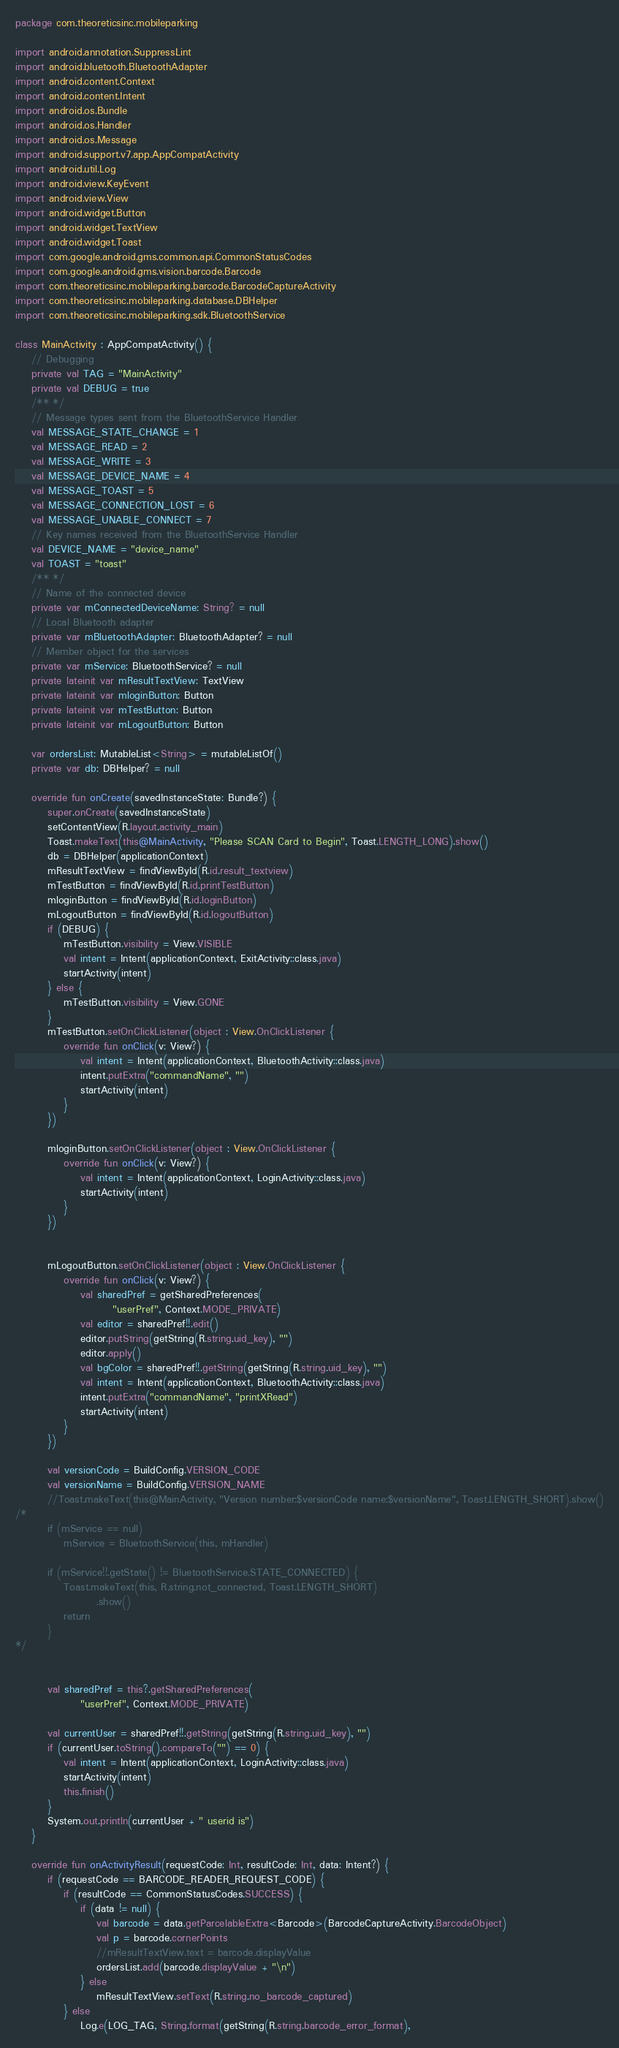<code> <loc_0><loc_0><loc_500><loc_500><_Kotlin_>package com.theoreticsinc.mobileparking

import android.annotation.SuppressLint
import android.bluetooth.BluetoothAdapter
import android.content.Context
import android.content.Intent
import android.os.Bundle
import android.os.Handler
import android.os.Message
import android.support.v7.app.AppCompatActivity
import android.util.Log
import android.view.KeyEvent
import android.view.View
import android.widget.Button
import android.widget.TextView
import android.widget.Toast
import com.google.android.gms.common.api.CommonStatusCodes
import com.google.android.gms.vision.barcode.Barcode
import com.theoreticsinc.mobileparking.barcode.BarcodeCaptureActivity
import com.theoreticsinc.mobileparking.database.DBHelper
import com.theoreticsinc.mobileparking.sdk.BluetoothService

class MainActivity : AppCompatActivity() {
    // Debugging
    private val TAG = "MainActivity"
    private val DEBUG = true
    /** */
    // Message types sent from the BluetoothService Handler
    val MESSAGE_STATE_CHANGE = 1
    val MESSAGE_READ = 2
    val MESSAGE_WRITE = 3
    val MESSAGE_DEVICE_NAME = 4
    val MESSAGE_TOAST = 5
    val MESSAGE_CONNECTION_LOST = 6
    val MESSAGE_UNABLE_CONNECT = 7
    // Key names received from the BluetoothService Handler
    val DEVICE_NAME = "device_name"
    val TOAST = "toast"
    /** */
    // Name of the connected device
    private var mConnectedDeviceName: String? = null
    // Local Bluetooth adapter
    private var mBluetoothAdapter: BluetoothAdapter? = null
    // Member object for the services
    private var mService: BluetoothService? = null
    private lateinit var mResultTextView: TextView
    private lateinit var mloginButton: Button
    private lateinit var mTestButton: Button
    private lateinit var mLogoutButton: Button

    var ordersList: MutableList<String> = mutableListOf()
    private var db: DBHelper? = null

    override fun onCreate(savedInstanceState: Bundle?) {
        super.onCreate(savedInstanceState)
        setContentView(R.layout.activity_main)
        Toast.makeText(this@MainActivity, "Please SCAN Card to Begin", Toast.LENGTH_LONG).show()
        db = DBHelper(applicationContext)
        mResultTextView = findViewById(R.id.result_textview)
        mTestButton = findViewById(R.id.printTestButton)
        mloginButton = findViewById(R.id.loginButton)
        mLogoutButton = findViewById(R.id.logoutButton)
        if (DEBUG) {
            mTestButton.visibility = View.VISIBLE
            val intent = Intent(applicationContext, ExitActivity::class.java)
            startActivity(intent)
        } else {
            mTestButton.visibility = View.GONE
        }
        mTestButton.setOnClickListener(object : View.OnClickListener {
            override fun onClick(v: View?) {
                val intent = Intent(applicationContext, BluetoothActivity::class.java)
                intent.putExtra("commandName", "")
                startActivity(intent)
            }
        })

        mloginButton.setOnClickListener(object : View.OnClickListener {
            override fun onClick(v: View?) {
                val intent = Intent(applicationContext, LoginActivity::class.java)
                startActivity(intent)
            }
        })


        mLogoutButton.setOnClickListener(object : View.OnClickListener {
            override fun onClick(v: View?) {
                val sharedPref = getSharedPreferences(
                        "userPref", Context.MODE_PRIVATE)
                val editor = sharedPref!!.edit()
                editor.putString(getString(R.string.uid_key), "")
                editor.apply()
                val bgColor = sharedPref!!.getString(getString(R.string.uid_key), "")
                val intent = Intent(applicationContext, BluetoothActivity::class.java)
                intent.putExtra("commandName", "printXRead")
                startActivity(intent)
            }
        })

        val versionCode = BuildConfig.VERSION_CODE
        val versionName = BuildConfig.VERSION_NAME
        //Toast.makeText(this@MainActivity, "Version number:$versionCode name:$versionName", Toast.LENGTH_SHORT).show()
/*
        if (mService == null)
            mService = BluetoothService(this, mHandler)

        if (mService!!.getState() != BluetoothService.STATE_CONNECTED) {
            Toast.makeText(this, R.string.not_connected, Toast.LENGTH_SHORT)
                    .show()
            return
        }
*/


        val sharedPref = this?.getSharedPreferences(
                "userPref", Context.MODE_PRIVATE)

        val currentUser = sharedPref!!.getString(getString(R.string.uid_key), "")
        if (currentUser.toString().compareTo("") == 0) {
            val intent = Intent(applicationContext, LoginActivity::class.java)
            startActivity(intent)
            this.finish()
        }
        System.out.println(currentUser + " userid is")
    }

    override fun onActivityResult(requestCode: Int, resultCode: Int, data: Intent?) {
        if (requestCode == BARCODE_READER_REQUEST_CODE) {
            if (resultCode == CommonStatusCodes.SUCCESS) {
                if (data != null) {
                    val barcode = data.getParcelableExtra<Barcode>(BarcodeCaptureActivity.BarcodeObject)
                    val p = barcode.cornerPoints
                    //mResultTextView.text = barcode.displayValue
                    ordersList.add(barcode.displayValue + "\n")
                } else
                    mResultTextView.setText(R.string.no_barcode_captured)
            } else
                Log.e(LOG_TAG, String.format(getString(R.string.barcode_error_format),</code> 